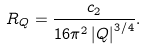Convert formula to latex. <formula><loc_0><loc_0><loc_500><loc_500>R _ { Q } = \frac { c _ { 2 } } { 1 6 \pi ^ { 2 } \left | Q \right | ^ { 3 / 4 } } .</formula> 